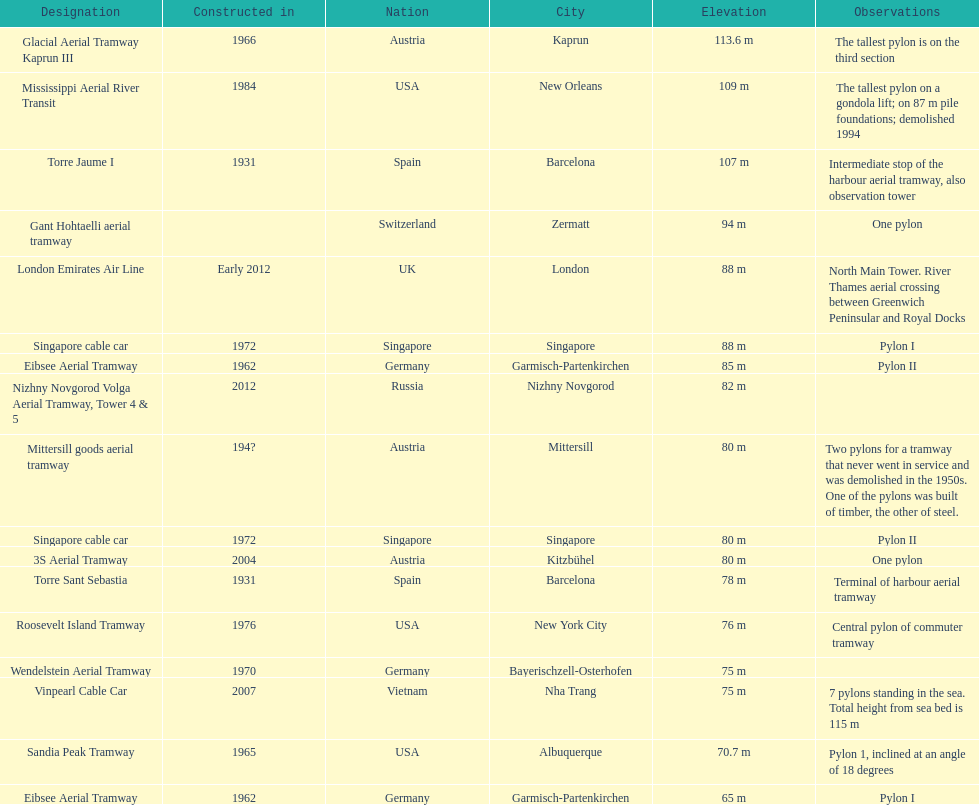Parse the table in full. {'header': ['Designation', 'Constructed in', 'Nation', 'City', 'Elevation', 'Observations'], 'rows': [['Glacial Aerial Tramway Kaprun III', '1966', 'Austria', 'Kaprun', '113.6 m', 'The tallest pylon is on the third section'], ['Mississippi Aerial River Transit', '1984', 'USA', 'New Orleans', '109 m', 'The tallest pylon on a gondola lift; on 87 m pile foundations; demolished 1994'], ['Torre Jaume I', '1931', 'Spain', 'Barcelona', '107 m', 'Intermediate stop of the harbour aerial tramway, also observation tower'], ['Gant Hohtaelli aerial tramway', '', 'Switzerland', 'Zermatt', '94 m', 'One pylon'], ['London Emirates Air Line', 'Early 2012', 'UK', 'London', '88 m', 'North Main Tower. River Thames aerial crossing between Greenwich Peninsular and Royal Docks'], ['Singapore cable car', '1972', 'Singapore', 'Singapore', '88 m', 'Pylon I'], ['Eibsee Aerial Tramway', '1962', 'Germany', 'Garmisch-Partenkirchen', '85 m', 'Pylon II'], ['Nizhny Novgorod Volga Aerial Tramway, Tower 4 & 5', '2012', 'Russia', 'Nizhny Novgorod', '82 m', ''], ['Mittersill goods aerial tramway', '194?', 'Austria', 'Mittersill', '80 m', 'Two pylons for a tramway that never went in service and was demolished in the 1950s. One of the pylons was built of timber, the other of steel.'], ['Singapore cable car', '1972', 'Singapore', 'Singapore', '80 m', 'Pylon II'], ['3S Aerial Tramway', '2004', 'Austria', 'Kitzbühel', '80 m', 'One pylon'], ['Torre Sant Sebastia', '1931', 'Spain', 'Barcelona', '78 m', 'Terminal of harbour aerial tramway'], ['Roosevelt Island Tramway', '1976', 'USA', 'New York City', '76 m', 'Central pylon of commuter tramway'], ['Wendelstein Aerial Tramway', '1970', 'Germany', 'Bayerischzell-Osterhofen', '75 m', ''], ['Vinpearl Cable Car', '2007', 'Vietnam', 'Nha Trang', '75 m', '7 pylons standing in the sea. Total height from sea bed is 115 m'], ['Sandia Peak Tramway', '1965', 'USA', 'Albuquerque', '70.7 m', 'Pylon 1, inclined at an angle of 18 degrees'], ['Eibsee Aerial Tramway', '1962', 'Germany', 'Garmisch-Partenkirchen', '65 m', 'Pylon I']]} Which pylon has the most remarks about it? Mittersill goods aerial tramway. 